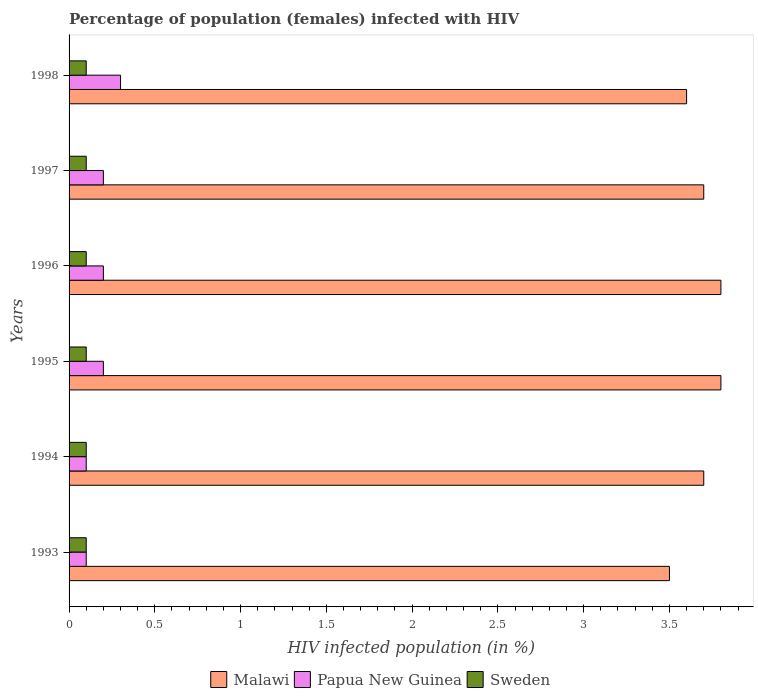How many different coloured bars are there?
Keep it short and to the point. 3. How many bars are there on the 4th tick from the top?
Make the answer very short. 3. What is the percentage of HIV infected female population in Malawi in 1997?
Provide a short and direct response. 3.7. Across all years, what is the minimum percentage of HIV infected female population in Sweden?
Give a very brief answer. 0.1. In which year was the percentage of HIV infected female population in Papua New Guinea maximum?
Give a very brief answer. 1998. What is the total percentage of HIV infected female population in Malawi in the graph?
Your answer should be compact. 22.1. What is the difference between the percentage of HIV infected female population in Sweden in 1996 and the percentage of HIV infected female population in Malawi in 1995?
Provide a short and direct response. -3.7. What is the average percentage of HIV infected female population in Papua New Guinea per year?
Offer a very short reply. 0.18. In the year 1995, what is the difference between the percentage of HIV infected female population in Papua New Guinea and percentage of HIV infected female population in Malawi?
Your answer should be compact. -3.6. In how many years, is the percentage of HIV infected female population in Papua New Guinea greater than 2 %?
Keep it short and to the point. 0. What is the ratio of the percentage of HIV infected female population in Malawi in 1997 to that in 1998?
Your response must be concise. 1.03. Is the percentage of HIV infected female population in Papua New Guinea in 1993 less than that in 1996?
Your answer should be compact. Yes. Is the difference between the percentage of HIV infected female population in Papua New Guinea in 1993 and 1995 greater than the difference between the percentage of HIV infected female population in Malawi in 1993 and 1995?
Your response must be concise. Yes. What is the difference between the highest and the lowest percentage of HIV infected female population in Papua New Guinea?
Your answer should be compact. 0.2. Is the sum of the percentage of HIV infected female population in Malawi in 1993 and 1998 greater than the maximum percentage of HIV infected female population in Sweden across all years?
Your response must be concise. Yes. What does the 1st bar from the top in 1994 represents?
Your answer should be very brief. Sweden. What does the 3rd bar from the bottom in 1997 represents?
Your answer should be very brief. Sweden. Are the values on the major ticks of X-axis written in scientific E-notation?
Offer a terse response. No. Does the graph contain grids?
Your response must be concise. No. How many legend labels are there?
Your answer should be compact. 3. What is the title of the graph?
Offer a very short reply. Percentage of population (females) infected with HIV. What is the label or title of the X-axis?
Give a very brief answer. HIV infected population (in %). What is the label or title of the Y-axis?
Offer a terse response. Years. What is the HIV infected population (in %) in Papua New Guinea in 1993?
Keep it short and to the point. 0.1. What is the HIV infected population (in %) of Sweden in 1994?
Provide a short and direct response. 0.1. What is the HIV infected population (in %) in Sweden in 1995?
Provide a succinct answer. 0.1. What is the HIV infected population (in %) of Malawi in 1996?
Provide a short and direct response. 3.8. What is the HIV infected population (in %) in Papua New Guinea in 1996?
Your response must be concise. 0.2. What is the HIV infected population (in %) in Papua New Guinea in 1997?
Keep it short and to the point. 0.2. What is the HIV infected population (in %) of Papua New Guinea in 1998?
Make the answer very short. 0.3. What is the HIV infected population (in %) of Sweden in 1998?
Provide a succinct answer. 0.1. Across all years, what is the maximum HIV infected population (in %) of Malawi?
Provide a short and direct response. 3.8. Across all years, what is the maximum HIV infected population (in %) of Papua New Guinea?
Offer a very short reply. 0.3. Across all years, what is the maximum HIV infected population (in %) in Sweden?
Offer a very short reply. 0.1. What is the total HIV infected population (in %) of Malawi in the graph?
Your answer should be compact. 22.1. What is the total HIV infected population (in %) in Papua New Guinea in the graph?
Ensure brevity in your answer.  1.1. What is the total HIV infected population (in %) in Sweden in the graph?
Your response must be concise. 0.6. What is the difference between the HIV infected population (in %) of Malawi in 1993 and that in 1994?
Give a very brief answer. -0.2. What is the difference between the HIV infected population (in %) of Malawi in 1993 and that in 1995?
Your answer should be very brief. -0.3. What is the difference between the HIV infected population (in %) of Papua New Guinea in 1993 and that in 1995?
Your answer should be very brief. -0.1. What is the difference between the HIV infected population (in %) of Sweden in 1993 and that in 1995?
Provide a short and direct response. 0. What is the difference between the HIV infected population (in %) in Malawi in 1993 and that in 1996?
Ensure brevity in your answer.  -0.3. What is the difference between the HIV infected population (in %) of Papua New Guinea in 1993 and that in 1996?
Provide a short and direct response. -0.1. What is the difference between the HIV infected population (in %) in Sweden in 1993 and that in 1996?
Your answer should be very brief. 0. What is the difference between the HIV infected population (in %) in Papua New Guinea in 1993 and that in 1997?
Offer a terse response. -0.1. What is the difference between the HIV infected population (in %) in Sweden in 1994 and that in 1995?
Make the answer very short. 0. What is the difference between the HIV infected population (in %) of Papua New Guinea in 1994 and that in 1996?
Make the answer very short. -0.1. What is the difference between the HIV infected population (in %) of Sweden in 1994 and that in 1996?
Offer a terse response. 0. What is the difference between the HIV infected population (in %) in Malawi in 1994 and that in 1997?
Offer a terse response. 0. What is the difference between the HIV infected population (in %) in Sweden in 1994 and that in 1998?
Give a very brief answer. 0. What is the difference between the HIV infected population (in %) of Malawi in 1995 and that in 1996?
Offer a terse response. 0. What is the difference between the HIV infected population (in %) of Papua New Guinea in 1995 and that in 1996?
Offer a terse response. 0. What is the difference between the HIV infected population (in %) in Sweden in 1995 and that in 1996?
Offer a very short reply. 0. What is the difference between the HIV infected population (in %) in Malawi in 1995 and that in 1997?
Keep it short and to the point. 0.1. What is the difference between the HIV infected population (in %) in Papua New Guinea in 1995 and that in 1998?
Make the answer very short. -0.1. What is the difference between the HIV infected population (in %) of Sweden in 1995 and that in 1998?
Provide a succinct answer. 0. What is the difference between the HIV infected population (in %) of Malawi in 1996 and that in 1998?
Your answer should be compact. 0.2. What is the difference between the HIV infected population (in %) in Malawi in 1997 and that in 1998?
Your answer should be very brief. 0.1. What is the difference between the HIV infected population (in %) of Papua New Guinea in 1997 and that in 1998?
Provide a short and direct response. -0.1. What is the difference between the HIV infected population (in %) in Malawi in 1993 and the HIV infected population (in %) in Papua New Guinea in 1998?
Offer a terse response. 3.2. What is the difference between the HIV infected population (in %) in Papua New Guinea in 1993 and the HIV infected population (in %) in Sweden in 1998?
Ensure brevity in your answer.  0. What is the difference between the HIV infected population (in %) in Malawi in 1994 and the HIV infected population (in %) in Papua New Guinea in 1995?
Your response must be concise. 3.5. What is the difference between the HIV infected population (in %) of Papua New Guinea in 1994 and the HIV infected population (in %) of Sweden in 1995?
Provide a short and direct response. 0. What is the difference between the HIV infected population (in %) of Malawi in 1994 and the HIV infected population (in %) of Papua New Guinea in 1996?
Offer a very short reply. 3.5. What is the difference between the HIV infected population (in %) of Papua New Guinea in 1994 and the HIV infected population (in %) of Sweden in 1996?
Make the answer very short. 0. What is the difference between the HIV infected population (in %) of Papua New Guinea in 1994 and the HIV infected population (in %) of Sweden in 1998?
Your answer should be compact. 0. What is the difference between the HIV infected population (in %) in Malawi in 1995 and the HIV infected population (in %) in Sweden in 1996?
Your response must be concise. 3.7. What is the difference between the HIV infected population (in %) in Malawi in 1995 and the HIV infected population (in %) in Sweden in 1997?
Provide a succinct answer. 3.7. What is the difference between the HIV infected population (in %) of Papua New Guinea in 1995 and the HIV infected population (in %) of Sweden in 1997?
Offer a terse response. 0.1. What is the difference between the HIV infected population (in %) of Papua New Guinea in 1995 and the HIV infected population (in %) of Sweden in 1998?
Give a very brief answer. 0.1. What is the difference between the HIV infected population (in %) in Malawi in 1996 and the HIV infected population (in %) in Sweden in 1997?
Your answer should be very brief. 3.7. What is the difference between the HIV infected population (in %) of Papua New Guinea in 1996 and the HIV infected population (in %) of Sweden in 1997?
Ensure brevity in your answer.  0.1. What is the difference between the HIV infected population (in %) in Malawi in 1996 and the HIV infected population (in %) in Sweden in 1998?
Give a very brief answer. 3.7. What is the difference between the HIV infected population (in %) in Papua New Guinea in 1996 and the HIV infected population (in %) in Sweden in 1998?
Your response must be concise. 0.1. What is the difference between the HIV infected population (in %) of Malawi in 1997 and the HIV infected population (in %) of Papua New Guinea in 1998?
Make the answer very short. 3.4. What is the average HIV infected population (in %) of Malawi per year?
Keep it short and to the point. 3.68. What is the average HIV infected population (in %) of Papua New Guinea per year?
Offer a terse response. 0.18. In the year 1993, what is the difference between the HIV infected population (in %) in Papua New Guinea and HIV infected population (in %) in Sweden?
Offer a very short reply. 0. In the year 1994, what is the difference between the HIV infected population (in %) of Malawi and HIV infected population (in %) of Papua New Guinea?
Your response must be concise. 3.6. In the year 1994, what is the difference between the HIV infected population (in %) of Malawi and HIV infected population (in %) of Sweden?
Provide a short and direct response. 3.6. In the year 1995, what is the difference between the HIV infected population (in %) in Papua New Guinea and HIV infected population (in %) in Sweden?
Provide a succinct answer. 0.1. In the year 1996, what is the difference between the HIV infected population (in %) in Malawi and HIV infected population (in %) in Sweden?
Your response must be concise. 3.7. In the year 1996, what is the difference between the HIV infected population (in %) in Papua New Guinea and HIV infected population (in %) in Sweden?
Provide a short and direct response. 0.1. In the year 1997, what is the difference between the HIV infected population (in %) in Malawi and HIV infected population (in %) in Sweden?
Offer a very short reply. 3.6. In the year 1997, what is the difference between the HIV infected population (in %) in Papua New Guinea and HIV infected population (in %) in Sweden?
Keep it short and to the point. 0.1. In the year 1998, what is the difference between the HIV infected population (in %) in Papua New Guinea and HIV infected population (in %) in Sweden?
Offer a terse response. 0.2. What is the ratio of the HIV infected population (in %) of Malawi in 1993 to that in 1994?
Offer a very short reply. 0.95. What is the ratio of the HIV infected population (in %) of Malawi in 1993 to that in 1995?
Offer a terse response. 0.92. What is the ratio of the HIV infected population (in %) in Malawi in 1993 to that in 1996?
Keep it short and to the point. 0.92. What is the ratio of the HIV infected population (in %) in Papua New Guinea in 1993 to that in 1996?
Provide a short and direct response. 0.5. What is the ratio of the HIV infected population (in %) of Sweden in 1993 to that in 1996?
Make the answer very short. 1. What is the ratio of the HIV infected population (in %) in Malawi in 1993 to that in 1997?
Your answer should be very brief. 0.95. What is the ratio of the HIV infected population (in %) of Sweden in 1993 to that in 1997?
Provide a short and direct response. 1. What is the ratio of the HIV infected population (in %) of Malawi in 1993 to that in 1998?
Give a very brief answer. 0.97. What is the ratio of the HIV infected population (in %) in Papua New Guinea in 1993 to that in 1998?
Provide a short and direct response. 0.33. What is the ratio of the HIV infected population (in %) in Malawi in 1994 to that in 1995?
Your answer should be very brief. 0.97. What is the ratio of the HIV infected population (in %) in Papua New Guinea in 1994 to that in 1995?
Give a very brief answer. 0.5. What is the ratio of the HIV infected population (in %) in Sweden in 1994 to that in 1995?
Your answer should be compact. 1. What is the ratio of the HIV infected population (in %) in Malawi in 1994 to that in 1996?
Give a very brief answer. 0.97. What is the ratio of the HIV infected population (in %) of Sweden in 1994 to that in 1996?
Your response must be concise. 1. What is the ratio of the HIV infected population (in %) of Malawi in 1994 to that in 1997?
Your answer should be compact. 1. What is the ratio of the HIV infected population (in %) of Papua New Guinea in 1994 to that in 1997?
Your response must be concise. 0.5. What is the ratio of the HIV infected population (in %) of Sweden in 1994 to that in 1997?
Offer a very short reply. 1. What is the ratio of the HIV infected population (in %) of Malawi in 1994 to that in 1998?
Your response must be concise. 1.03. What is the ratio of the HIV infected population (in %) in Sweden in 1995 to that in 1996?
Provide a succinct answer. 1. What is the ratio of the HIV infected population (in %) of Papua New Guinea in 1995 to that in 1997?
Offer a terse response. 1. What is the ratio of the HIV infected population (in %) of Sweden in 1995 to that in 1997?
Provide a short and direct response. 1. What is the ratio of the HIV infected population (in %) in Malawi in 1995 to that in 1998?
Offer a terse response. 1.06. What is the ratio of the HIV infected population (in %) of Papua New Guinea in 1995 to that in 1998?
Ensure brevity in your answer.  0.67. What is the ratio of the HIV infected population (in %) of Malawi in 1996 to that in 1997?
Offer a terse response. 1.03. What is the ratio of the HIV infected population (in %) in Papua New Guinea in 1996 to that in 1997?
Ensure brevity in your answer.  1. What is the ratio of the HIV infected population (in %) in Sweden in 1996 to that in 1997?
Your response must be concise. 1. What is the ratio of the HIV infected population (in %) of Malawi in 1996 to that in 1998?
Give a very brief answer. 1.06. What is the ratio of the HIV infected population (in %) in Papua New Guinea in 1996 to that in 1998?
Provide a succinct answer. 0.67. What is the ratio of the HIV infected population (in %) of Malawi in 1997 to that in 1998?
Provide a short and direct response. 1.03. What is the ratio of the HIV infected population (in %) of Papua New Guinea in 1997 to that in 1998?
Your answer should be very brief. 0.67. What is the ratio of the HIV infected population (in %) of Sweden in 1997 to that in 1998?
Give a very brief answer. 1. What is the difference between the highest and the lowest HIV infected population (in %) in Malawi?
Keep it short and to the point. 0.3. What is the difference between the highest and the lowest HIV infected population (in %) in Papua New Guinea?
Your response must be concise. 0.2. What is the difference between the highest and the lowest HIV infected population (in %) in Sweden?
Make the answer very short. 0. 